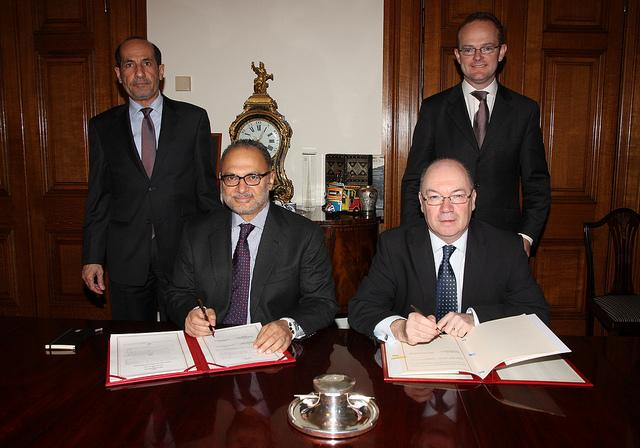What type of event is this?

Choices:
A) meeting
B) funeral
C) shower
D) wedding meeting 